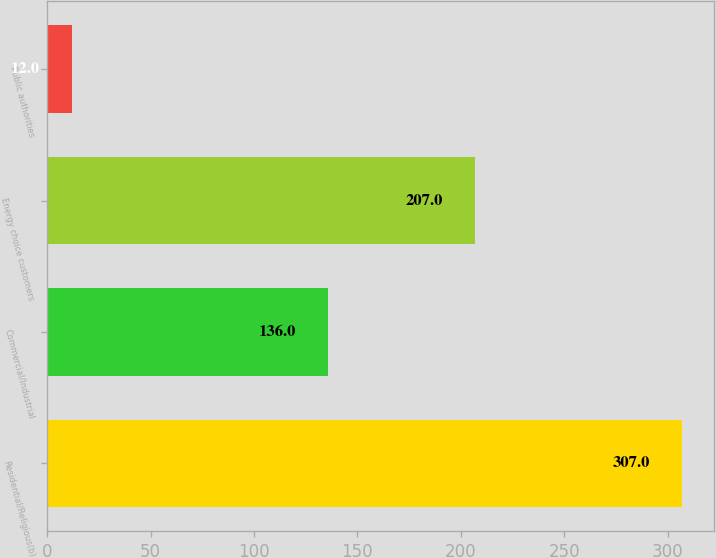Convert chart to OTSL. <chart><loc_0><loc_0><loc_500><loc_500><bar_chart><fcel>Residential/Religious(b)<fcel>Commercial/Industrial<fcel>Energy choice customers<fcel>Public authorities<nl><fcel>307<fcel>136<fcel>207<fcel>12<nl></chart> 